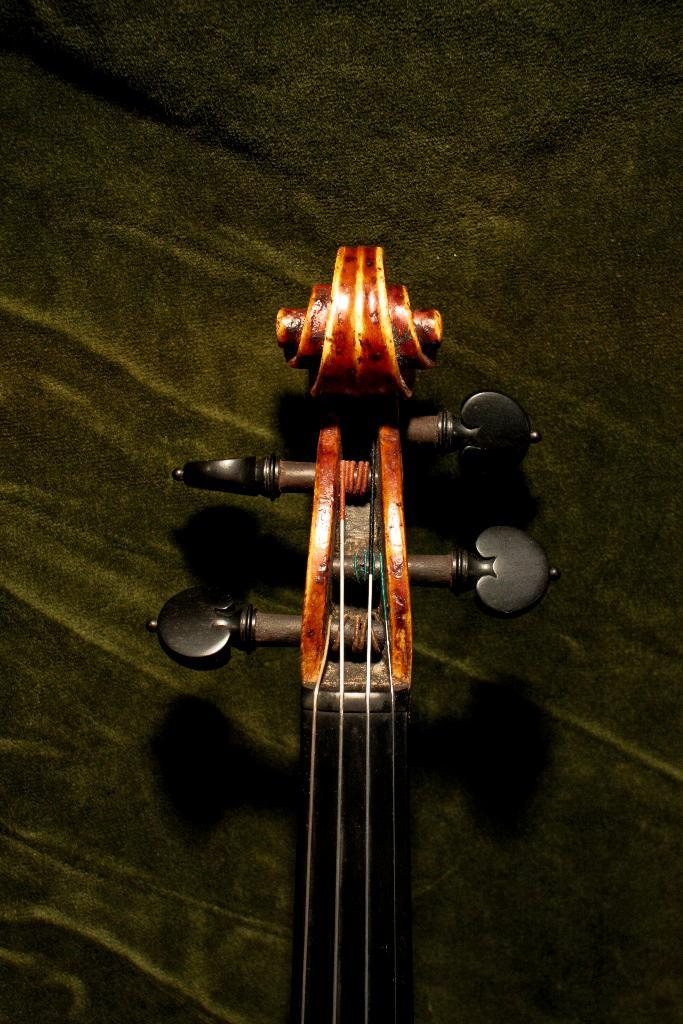What part of the guitar is the focus of the image? The guitar head is highlighted in the image. What can be seen on the guitar head? There are tuners visible in the image. How many parents are visible holding the guitar in the image? There are no parents visible in the image, and the guitar is not being held by anyone. 